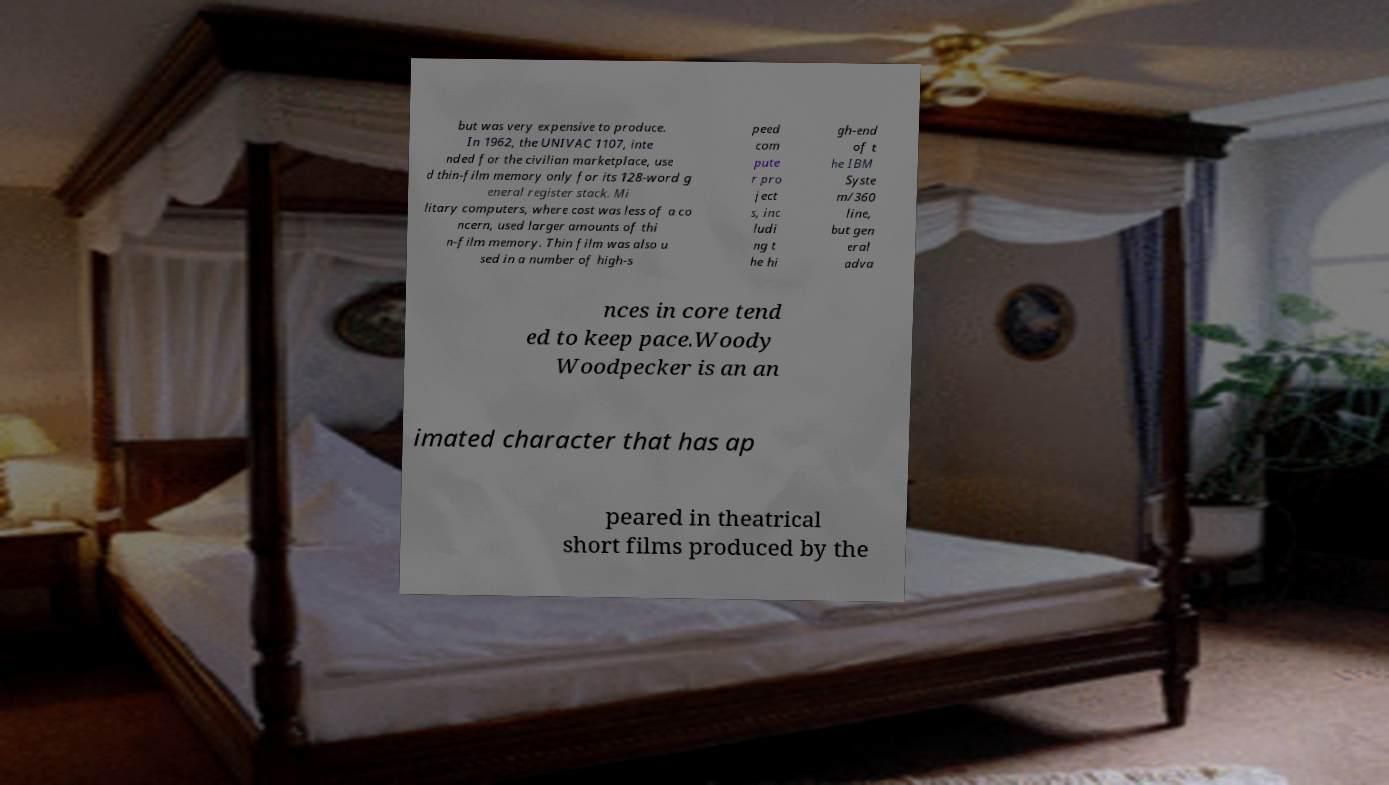Could you assist in decoding the text presented in this image and type it out clearly? but was very expensive to produce. In 1962, the UNIVAC 1107, inte nded for the civilian marketplace, use d thin-film memory only for its 128-word g eneral register stack. Mi litary computers, where cost was less of a co ncern, used larger amounts of thi n-film memory. Thin film was also u sed in a number of high-s peed com pute r pro ject s, inc ludi ng t he hi gh-end of t he IBM Syste m/360 line, but gen eral adva nces in core tend ed to keep pace.Woody Woodpecker is an an imated character that has ap peared in theatrical short films produced by the 